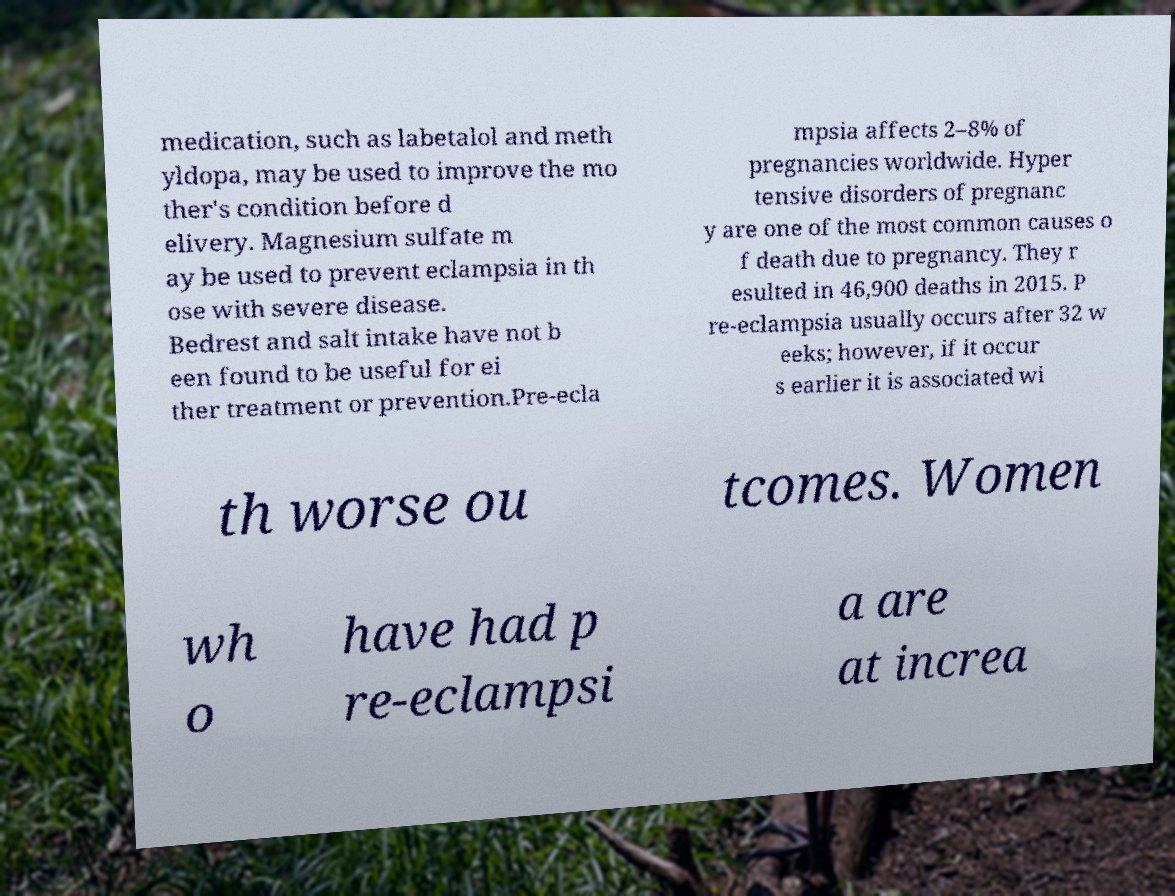Please identify and transcribe the text found in this image. medication, such as labetalol and meth yldopa, may be used to improve the mo ther's condition before d elivery. Magnesium sulfate m ay be used to prevent eclampsia in th ose with severe disease. Bedrest and salt intake have not b een found to be useful for ei ther treatment or prevention.Pre-ecla mpsia affects 2–8% of pregnancies worldwide. Hyper tensive disorders of pregnanc y are one of the most common causes o f death due to pregnancy. They r esulted in 46,900 deaths in 2015. P re-eclampsia usually occurs after 32 w eeks; however, if it occur s earlier it is associated wi th worse ou tcomes. Women wh o have had p re-eclampsi a are at increa 